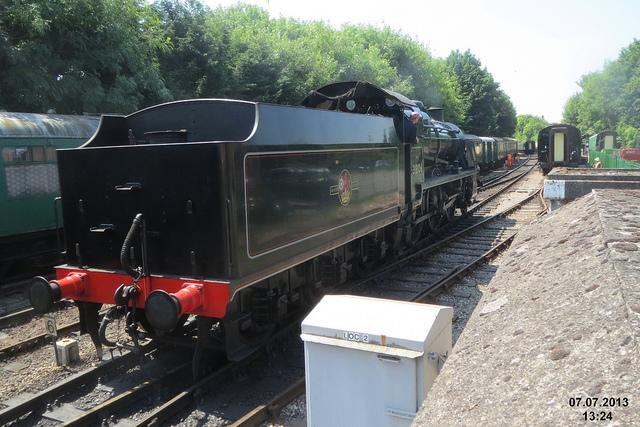The purpose of the train car behind the train engine is to hold what?

Choices:
A) water
B) coal
C) cargo
D) passengers coal 